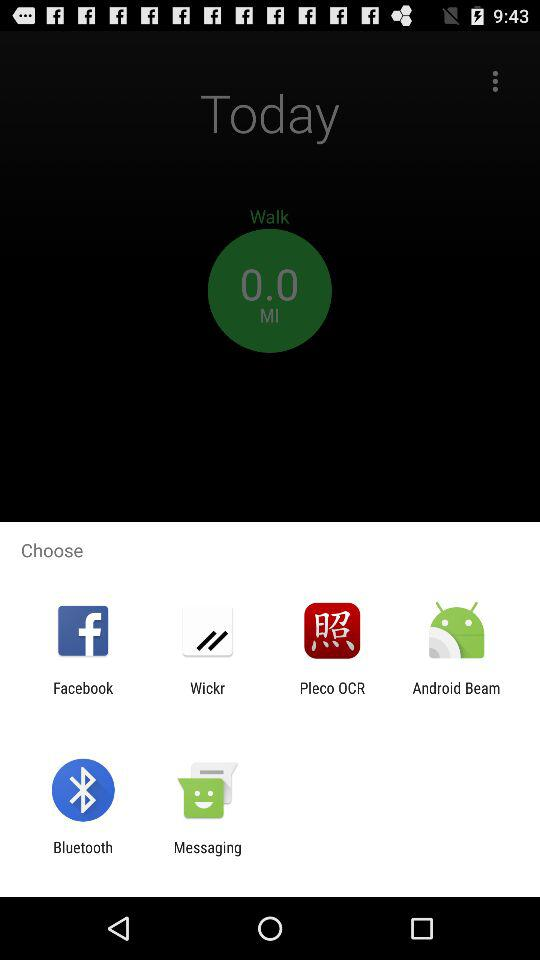Which applications can be used to choose? The applications are "Facebook", "Wickr", "Pleco OCR", "Android Beam", "Bluetooth" and "Messaging". 